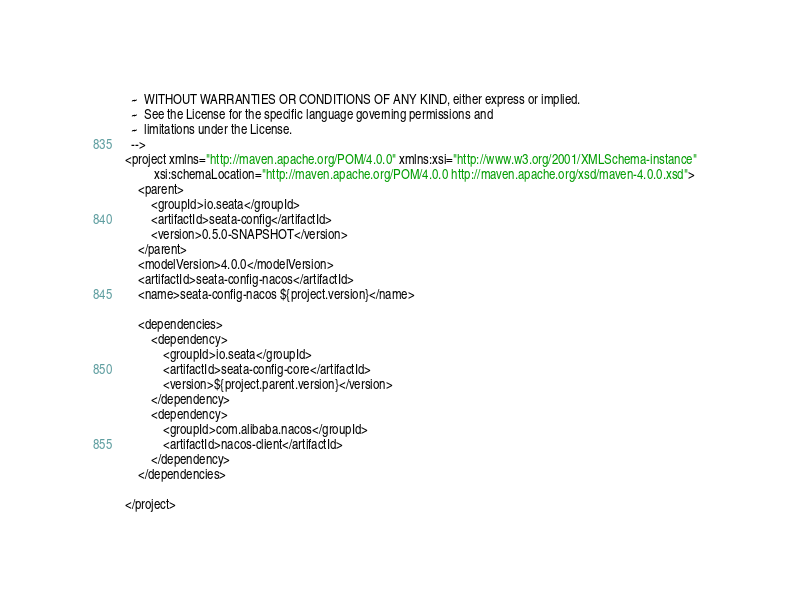<code> <loc_0><loc_0><loc_500><loc_500><_XML_>  ~  WITHOUT WARRANTIES OR CONDITIONS OF ANY KIND, either express or implied.
  ~  See the License for the specific language governing permissions and
  ~  limitations under the License.
  -->
<project xmlns="http://maven.apache.org/POM/4.0.0" xmlns:xsi="http://www.w3.org/2001/XMLSchema-instance"
         xsi:schemaLocation="http://maven.apache.org/POM/4.0.0 http://maven.apache.org/xsd/maven-4.0.0.xsd">
    <parent>
        <groupId>io.seata</groupId>
        <artifactId>seata-config</artifactId>
        <version>0.5.0-SNAPSHOT</version>
    </parent>
    <modelVersion>4.0.0</modelVersion>
    <artifactId>seata-config-nacos</artifactId>
    <name>seata-config-nacos ${project.version}</name>

    <dependencies>
        <dependency>
            <groupId>io.seata</groupId>
            <artifactId>seata-config-core</artifactId>
            <version>${project.parent.version}</version>
        </dependency>
        <dependency>
            <groupId>com.alibaba.nacos</groupId>
            <artifactId>nacos-client</artifactId>
        </dependency>
    </dependencies>

</project>
</code> 